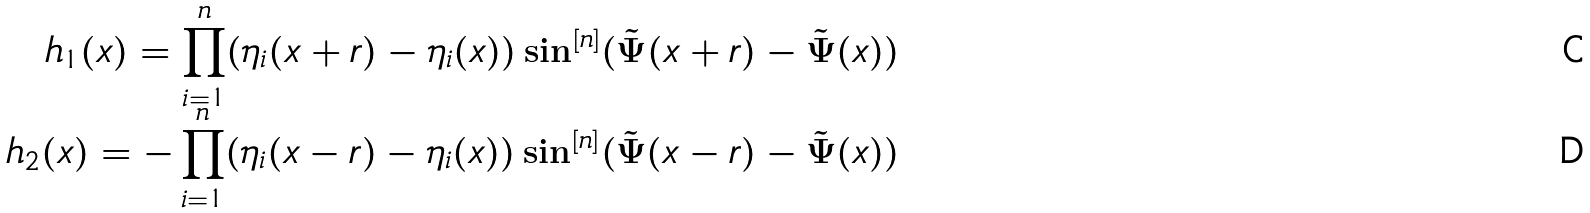<formula> <loc_0><loc_0><loc_500><loc_500>h _ { 1 } ( x ) = \prod _ { i = 1 } ^ { n } ( \eta _ { i } ( x + r ) - \eta _ { i } ( x ) ) \sin ^ { [ n ] } ( \tilde { \Psi } ( x + r ) - \tilde { \Psi } ( x ) ) \\ h _ { 2 } ( x ) = - \prod _ { i = 1 } ^ { n } ( \eta _ { i } ( x - r ) - \eta _ { i } ( x ) ) \sin ^ { [ n ] } ( \tilde { \Psi } ( x - r ) - \tilde { \Psi } ( x ) )</formula> 